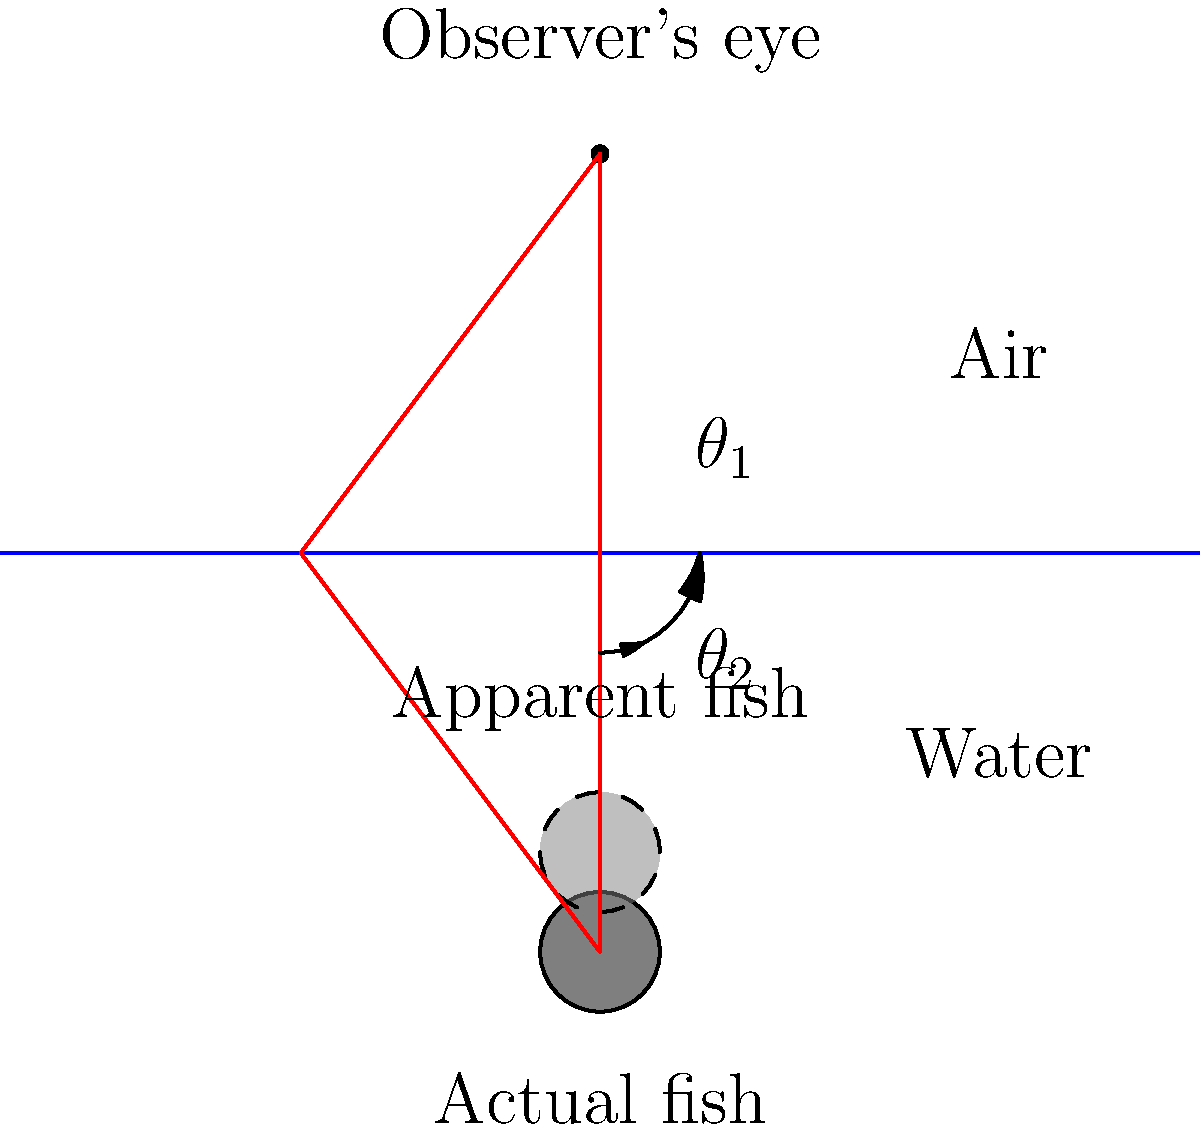As you research for your novel about survival, you come across the challenge of spearfishing. When aiming at a fish underwater, you notice that the fish appears to be in a different position than it actually is. If the angle of incidence of the light ray in air is $\theta_1 = 30°$ and the refractive index of water is 1.33, what is the actual depth of the fish if it appears to be 1.5 meters deep? Let's approach this step-by-step:

1) First, we need to use Snell's law to find the angle of refraction ($\theta_2$) in water:
   
   $n_1 \sin(\theta_1) = n_2 \sin(\theta_2)$

   Where $n_1 = 1$ (air), $n_2 = 1.33$ (water), and $\theta_1 = 30°$

2) Plugging in the values:

   $1 \sin(30°) = 1.33 \sin(\theta_2)$

3) Solving for $\theta_2$:

   $\sin(\theta_2) = \frac{1 \sin(30°)}{1.33} \approx 0.3759$
   
   $\theta_2 \approx 22.1°$

4) Now, we can use the ratio of the tangents of these angles to find the ratio of apparent depth to actual depth:

   $\frac{\text{apparent depth}}{\text{actual depth}} = \frac{\tan(\theta_2)}{\tan(\theta_1)}$

5) Plugging in the values:

   $\frac{1.5}{\text{actual depth}} = \frac{\tan(22.1°)}{\tan(30°)}$

6) Solving for the actual depth:

   $\text{actual depth} = 1.5 \cdot \frac{\tan(30°)}{\tan(22.1°)} \approx 2 \text{ meters}$

Therefore, the actual depth of the fish is approximately 2 meters.
Answer: 2 meters 